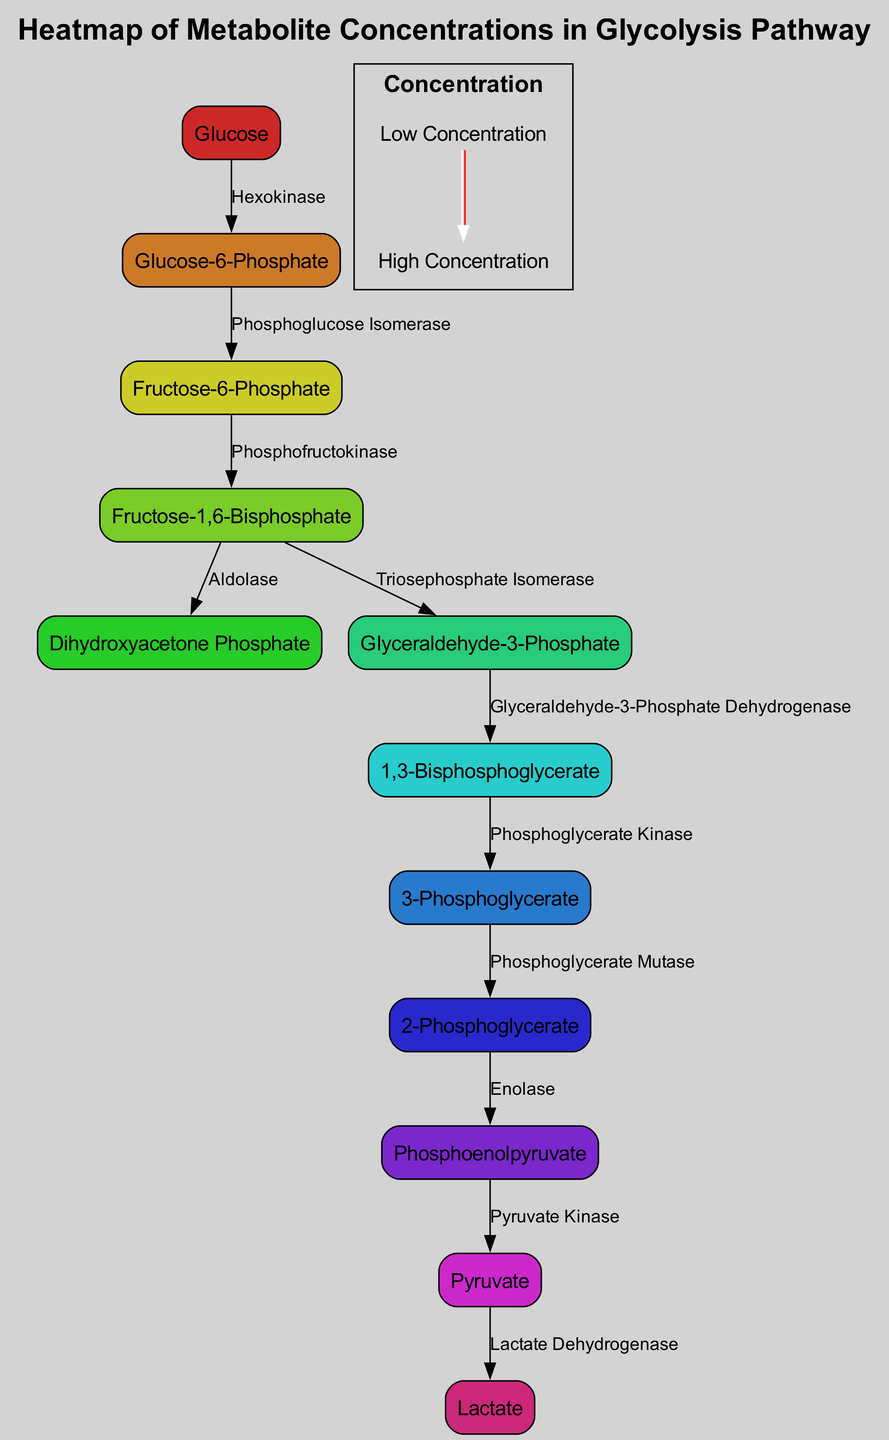What is the starting metabolite in the glycolysis pathway? The starting metabolite in the glycolysis pathway is identified as "Glucose," which is represented as the first node in the diagram.
Answer: Glucose How many metabolites are displayed in the pathway? To find the total number of metabolites, we count each node listed in the "nodes" section of the data. There are 12 nodes in total.
Answer: 12 What enzyme is responsible for converting Glucose to Glucose-6-Phosphate? The transition from "Glucose" to "Glucose-6-Phosphate" is facilitated by the enzyme "Hexokinase," which is labeled on the edge connecting these two nodes.
Answer: Hexokinase Which metabolite follows Fructose-1,6-Bisphosphate in the pathway? The diagram shows that from "Fructose-1,6-Bisphosphate," there are two branches: one leads to "Dihydroxyacetone Phosphate" and the other to "Glyceraldehyde-3-Phosphate." The first metabolite encountered after "Fructose-1,6-Bisphosphate" in the pathway is "Dihydroxyacetone Phosphate".
Answer: Dihydroxyacetone Phosphate What is the final product of the glycolysis pathway according to the diagram? As we trace the pathway from the final nodes, "Pyruvate" is the last metabolite listed before indicating the conversion to "Lactate," making it the primary end product of glycolysis highlighted in the diagram.
Answer: Pyruvate How many enzymatic reactions occur from the starting metabolite to the final product? The path from "Glucose" to "Lactate" is represented by 10 enzymatic reactions, which can be counted by analyzing each edge connecting the nodes from start to finish.
Answer: 10 What color corresponds to the lowest concentration level in the heatmap? The lowest concentration level in the heatmap is represented by the color white, as described in the color scale section of the data.
Answer: White What two metabolites are produced from Fructose-1,6-Bisphosphate? The two metabolites produced when "Fructose-1,6-Bisphosphate" is processed are "Dihydroxyacetone Phosphate" and "Glyceraldehyde-3-Phosphate," as indicated by the two edges branching from this node.
Answer: Dihydroxyacetone Phosphate, Glyceraldehyde-3-Phosphate Which enzyme is depicted as linking 1,3-Bisphosphoglycerate to 3-Phosphoglycerate? The enzyme responsible for converting "1,3-Bisphosphoglycerate" to "3-Phosphoglycerate" is labeled as "Phosphoglycerate Kinase" on the connecting edge in the diagram.
Answer: Phosphoglycerate Kinase 